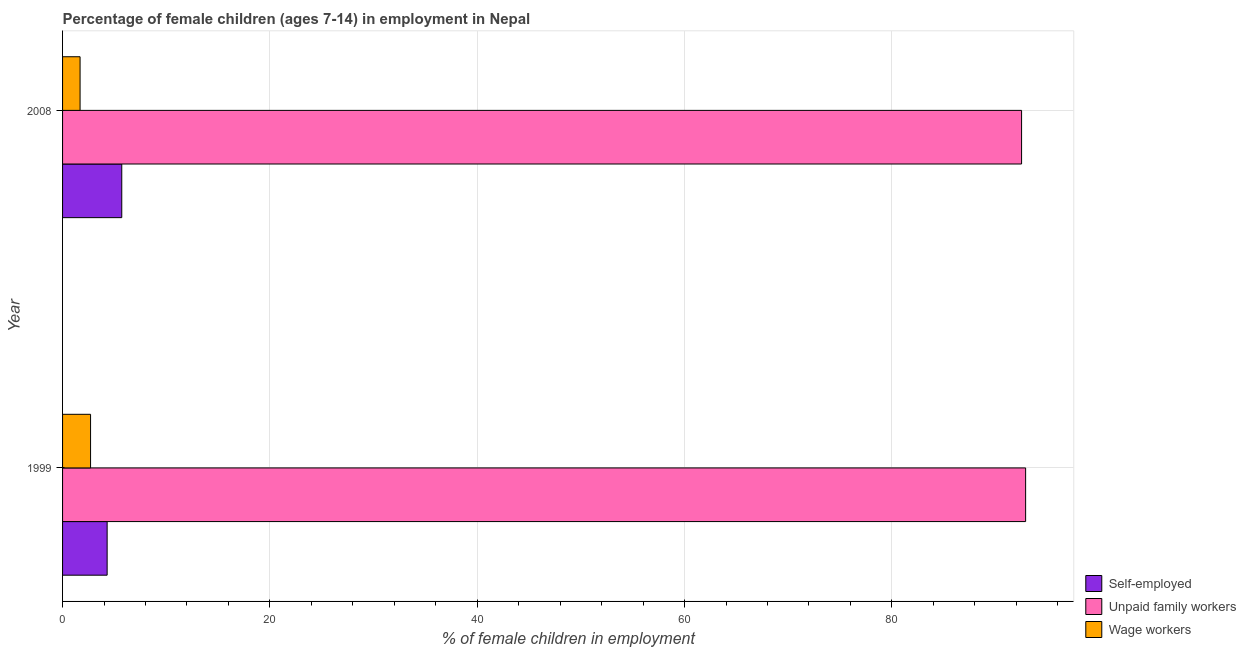How many different coloured bars are there?
Provide a short and direct response. 3. How many groups of bars are there?
Your answer should be compact. 2. How many bars are there on the 2nd tick from the top?
Provide a short and direct response. 3. What is the percentage of children employed as unpaid family workers in 2008?
Give a very brief answer. 92.51. Across all years, what is the maximum percentage of children employed as wage workers?
Your answer should be compact. 2.7. Across all years, what is the minimum percentage of children employed as wage workers?
Keep it short and to the point. 1.69. In which year was the percentage of children employed as wage workers minimum?
Keep it short and to the point. 2008. What is the total percentage of self employed children in the graph?
Give a very brief answer. 10.01. What is the difference between the percentage of children employed as unpaid family workers in 2008 and the percentage of children employed as wage workers in 1999?
Your response must be concise. 89.81. What is the average percentage of children employed as unpaid family workers per year?
Your response must be concise. 92.7. In the year 1999, what is the difference between the percentage of self employed children and percentage of children employed as unpaid family workers?
Offer a very short reply. -88.6. In how many years, is the percentage of self employed children greater than 88 %?
Make the answer very short. 0. What is the ratio of the percentage of children employed as wage workers in 1999 to that in 2008?
Keep it short and to the point. 1.6. Is the difference between the percentage of children employed as wage workers in 1999 and 2008 greater than the difference between the percentage of self employed children in 1999 and 2008?
Give a very brief answer. Yes. What does the 2nd bar from the top in 1999 represents?
Offer a terse response. Unpaid family workers. What does the 2nd bar from the bottom in 1999 represents?
Keep it short and to the point. Unpaid family workers. Is it the case that in every year, the sum of the percentage of self employed children and percentage of children employed as unpaid family workers is greater than the percentage of children employed as wage workers?
Your answer should be compact. Yes. How many bars are there?
Keep it short and to the point. 6. How are the legend labels stacked?
Provide a short and direct response. Vertical. What is the title of the graph?
Your response must be concise. Percentage of female children (ages 7-14) in employment in Nepal. What is the label or title of the X-axis?
Provide a succinct answer. % of female children in employment. What is the % of female children in employment of Unpaid family workers in 1999?
Provide a succinct answer. 92.9. What is the % of female children in employment in Self-employed in 2008?
Provide a succinct answer. 5.71. What is the % of female children in employment of Unpaid family workers in 2008?
Your response must be concise. 92.51. What is the % of female children in employment of Wage workers in 2008?
Offer a very short reply. 1.69. Across all years, what is the maximum % of female children in employment in Self-employed?
Your response must be concise. 5.71. Across all years, what is the maximum % of female children in employment of Unpaid family workers?
Offer a very short reply. 92.9. Across all years, what is the minimum % of female children in employment in Self-employed?
Offer a very short reply. 4.3. Across all years, what is the minimum % of female children in employment of Unpaid family workers?
Your answer should be compact. 92.51. Across all years, what is the minimum % of female children in employment of Wage workers?
Ensure brevity in your answer.  1.69. What is the total % of female children in employment in Self-employed in the graph?
Keep it short and to the point. 10.01. What is the total % of female children in employment of Unpaid family workers in the graph?
Your answer should be very brief. 185.41. What is the total % of female children in employment of Wage workers in the graph?
Your response must be concise. 4.39. What is the difference between the % of female children in employment in Self-employed in 1999 and that in 2008?
Provide a short and direct response. -1.41. What is the difference between the % of female children in employment of Unpaid family workers in 1999 and that in 2008?
Provide a short and direct response. 0.39. What is the difference between the % of female children in employment of Self-employed in 1999 and the % of female children in employment of Unpaid family workers in 2008?
Your answer should be very brief. -88.21. What is the difference between the % of female children in employment in Self-employed in 1999 and the % of female children in employment in Wage workers in 2008?
Your response must be concise. 2.61. What is the difference between the % of female children in employment of Unpaid family workers in 1999 and the % of female children in employment of Wage workers in 2008?
Offer a terse response. 91.21. What is the average % of female children in employment of Self-employed per year?
Keep it short and to the point. 5. What is the average % of female children in employment of Unpaid family workers per year?
Provide a short and direct response. 92.7. What is the average % of female children in employment of Wage workers per year?
Your answer should be compact. 2.19. In the year 1999, what is the difference between the % of female children in employment of Self-employed and % of female children in employment of Unpaid family workers?
Provide a short and direct response. -88.6. In the year 1999, what is the difference between the % of female children in employment in Unpaid family workers and % of female children in employment in Wage workers?
Offer a very short reply. 90.2. In the year 2008, what is the difference between the % of female children in employment of Self-employed and % of female children in employment of Unpaid family workers?
Keep it short and to the point. -86.8. In the year 2008, what is the difference between the % of female children in employment in Self-employed and % of female children in employment in Wage workers?
Provide a succinct answer. 4.02. In the year 2008, what is the difference between the % of female children in employment of Unpaid family workers and % of female children in employment of Wage workers?
Provide a succinct answer. 90.82. What is the ratio of the % of female children in employment of Self-employed in 1999 to that in 2008?
Your response must be concise. 0.75. What is the ratio of the % of female children in employment of Unpaid family workers in 1999 to that in 2008?
Your response must be concise. 1. What is the ratio of the % of female children in employment in Wage workers in 1999 to that in 2008?
Provide a short and direct response. 1.6. What is the difference between the highest and the second highest % of female children in employment in Self-employed?
Give a very brief answer. 1.41. What is the difference between the highest and the second highest % of female children in employment in Unpaid family workers?
Your response must be concise. 0.39. What is the difference between the highest and the second highest % of female children in employment in Wage workers?
Offer a very short reply. 1.01. What is the difference between the highest and the lowest % of female children in employment of Self-employed?
Give a very brief answer. 1.41. What is the difference between the highest and the lowest % of female children in employment in Unpaid family workers?
Provide a succinct answer. 0.39. 